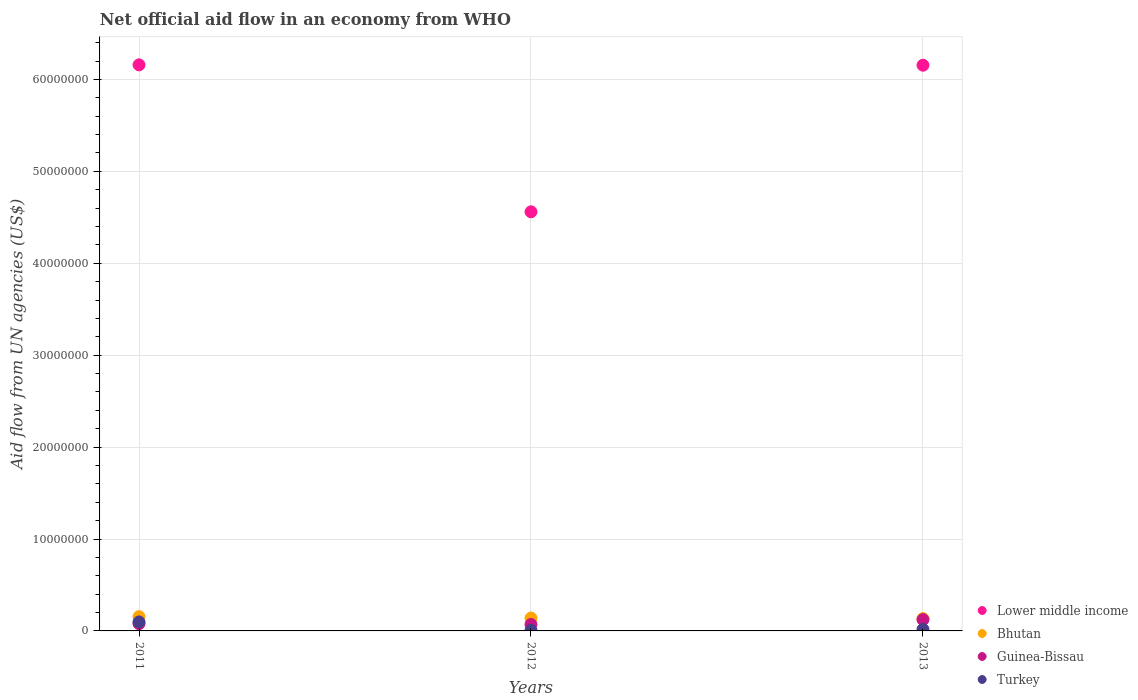What is the net official aid flow in Turkey in 2011?
Ensure brevity in your answer.  9.80e+05. Across all years, what is the maximum net official aid flow in Guinea-Bissau?
Your answer should be very brief. 1.23e+06. What is the total net official aid flow in Turkey in the graph?
Make the answer very short. 1.21e+06. What is the difference between the net official aid flow in Bhutan in 2012 and that in 2013?
Your answer should be compact. 6.00e+04. What is the difference between the net official aid flow in Turkey in 2011 and the net official aid flow in Bhutan in 2013?
Your answer should be compact. -3.60e+05. What is the average net official aid flow in Lower middle income per year?
Offer a very short reply. 5.62e+07. In the year 2012, what is the difference between the net official aid flow in Guinea-Bissau and net official aid flow in Turkey?
Your answer should be compact. 6.40e+05. What is the ratio of the net official aid flow in Guinea-Bissau in 2011 to that in 2013?
Provide a succinct answer. 0.64. Is the net official aid flow in Lower middle income in 2011 less than that in 2012?
Provide a succinct answer. No. Is the difference between the net official aid flow in Guinea-Bissau in 2012 and 2013 greater than the difference between the net official aid flow in Turkey in 2012 and 2013?
Make the answer very short. No. What is the difference between the highest and the second highest net official aid flow in Lower middle income?
Offer a very short reply. 4.00e+04. What is the difference between the highest and the lowest net official aid flow in Guinea-Bissau?
Offer a terse response. 5.30e+05. In how many years, is the net official aid flow in Turkey greater than the average net official aid flow in Turkey taken over all years?
Provide a short and direct response. 1. Is it the case that in every year, the sum of the net official aid flow in Lower middle income and net official aid flow in Guinea-Bissau  is greater than the net official aid flow in Turkey?
Give a very brief answer. Yes. Does the net official aid flow in Lower middle income monotonically increase over the years?
Your answer should be very brief. No. Is the net official aid flow in Guinea-Bissau strictly less than the net official aid flow in Bhutan over the years?
Your answer should be compact. Yes. How many dotlines are there?
Keep it short and to the point. 4. How many years are there in the graph?
Provide a short and direct response. 3. Where does the legend appear in the graph?
Give a very brief answer. Bottom right. What is the title of the graph?
Keep it short and to the point. Net official aid flow in an economy from WHO. What is the label or title of the Y-axis?
Give a very brief answer. Aid flow from UN agencies (US$). What is the Aid flow from UN agencies (US$) of Lower middle income in 2011?
Your response must be concise. 6.16e+07. What is the Aid flow from UN agencies (US$) of Bhutan in 2011?
Make the answer very short. 1.55e+06. What is the Aid flow from UN agencies (US$) of Guinea-Bissau in 2011?
Provide a short and direct response. 7.90e+05. What is the Aid flow from UN agencies (US$) in Turkey in 2011?
Your answer should be very brief. 9.80e+05. What is the Aid flow from UN agencies (US$) of Lower middle income in 2012?
Provide a short and direct response. 4.56e+07. What is the Aid flow from UN agencies (US$) in Bhutan in 2012?
Your answer should be compact. 1.40e+06. What is the Aid flow from UN agencies (US$) of Lower middle income in 2013?
Your answer should be compact. 6.16e+07. What is the Aid flow from UN agencies (US$) in Bhutan in 2013?
Ensure brevity in your answer.  1.34e+06. What is the Aid flow from UN agencies (US$) of Guinea-Bissau in 2013?
Offer a terse response. 1.23e+06. Across all years, what is the maximum Aid flow from UN agencies (US$) in Lower middle income?
Your answer should be very brief. 6.16e+07. Across all years, what is the maximum Aid flow from UN agencies (US$) of Bhutan?
Give a very brief answer. 1.55e+06. Across all years, what is the maximum Aid flow from UN agencies (US$) of Guinea-Bissau?
Give a very brief answer. 1.23e+06. Across all years, what is the maximum Aid flow from UN agencies (US$) in Turkey?
Ensure brevity in your answer.  9.80e+05. Across all years, what is the minimum Aid flow from UN agencies (US$) of Lower middle income?
Your answer should be compact. 4.56e+07. Across all years, what is the minimum Aid flow from UN agencies (US$) in Bhutan?
Keep it short and to the point. 1.34e+06. Across all years, what is the minimum Aid flow from UN agencies (US$) of Turkey?
Ensure brevity in your answer.  6.00e+04. What is the total Aid flow from UN agencies (US$) in Lower middle income in the graph?
Make the answer very short. 1.69e+08. What is the total Aid flow from UN agencies (US$) of Bhutan in the graph?
Make the answer very short. 4.29e+06. What is the total Aid flow from UN agencies (US$) of Guinea-Bissau in the graph?
Offer a very short reply. 2.72e+06. What is the total Aid flow from UN agencies (US$) of Turkey in the graph?
Give a very brief answer. 1.21e+06. What is the difference between the Aid flow from UN agencies (US$) in Lower middle income in 2011 and that in 2012?
Provide a short and direct response. 1.60e+07. What is the difference between the Aid flow from UN agencies (US$) of Guinea-Bissau in 2011 and that in 2012?
Provide a succinct answer. 9.00e+04. What is the difference between the Aid flow from UN agencies (US$) of Turkey in 2011 and that in 2012?
Your answer should be very brief. 9.20e+05. What is the difference between the Aid flow from UN agencies (US$) of Lower middle income in 2011 and that in 2013?
Provide a short and direct response. 4.00e+04. What is the difference between the Aid flow from UN agencies (US$) of Bhutan in 2011 and that in 2013?
Provide a succinct answer. 2.10e+05. What is the difference between the Aid flow from UN agencies (US$) of Guinea-Bissau in 2011 and that in 2013?
Keep it short and to the point. -4.40e+05. What is the difference between the Aid flow from UN agencies (US$) in Turkey in 2011 and that in 2013?
Offer a very short reply. 8.10e+05. What is the difference between the Aid flow from UN agencies (US$) of Lower middle income in 2012 and that in 2013?
Your response must be concise. -1.60e+07. What is the difference between the Aid flow from UN agencies (US$) of Bhutan in 2012 and that in 2013?
Your answer should be compact. 6.00e+04. What is the difference between the Aid flow from UN agencies (US$) in Guinea-Bissau in 2012 and that in 2013?
Ensure brevity in your answer.  -5.30e+05. What is the difference between the Aid flow from UN agencies (US$) in Turkey in 2012 and that in 2013?
Offer a terse response. -1.10e+05. What is the difference between the Aid flow from UN agencies (US$) in Lower middle income in 2011 and the Aid flow from UN agencies (US$) in Bhutan in 2012?
Give a very brief answer. 6.02e+07. What is the difference between the Aid flow from UN agencies (US$) of Lower middle income in 2011 and the Aid flow from UN agencies (US$) of Guinea-Bissau in 2012?
Provide a succinct answer. 6.09e+07. What is the difference between the Aid flow from UN agencies (US$) in Lower middle income in 2011 and the Aid flow from UN agencies (US$) in Turkey in 2012?
Offer a very short reply. 6.15e+07. What is the difference between the Aid flow from UN agencies (US$) of Bhutan in 2011 and the Aid flow from UN agencies (US$) of Guinea-Bissau in 2012?
Keep it short and to the point. 8.50e+05. What is the difference between the Aid flow from UN agencies (US$) in Bhutan in 2011 and the Aid flow from UN agencies (US$) in Turkey in 2012?
Provide a short and direct response. 1.49e+06. What is the difference between the Aid flow from UN agencies (US$) of Guinea-Bissau in 2011 and the Aid flow from UN agencies (US$) of Turkey in 2012?
Offer a very short reply. 7.30e+05. What is the difference between the Aid flow from UN agencies (US$) of Lower middle income in 2011 and the Aid flow from UN agencies (US$) of Bhutan in 2013?
Your response must be concise. 6.02e+07. What is the difference between the Aid flow from UN agencies (US$) of Lower middle income in 2011 and the Aid flow from UN agencies (US$) of Guinea-Bissau in 2013?
Give a very brief answer. 6.04e+07. What is the difference between the Aid flow from UN agencies (US$) of Lower middle income in 2011 and the Aid flow from UN agencies (US$) of Turkey in 2013?
Make the answer very short. 6.14e+07. What is the difference between the Aid flow from UN agencies (US$) of Bhutan in 2011 and the Aid flow from UN agencies (US$) of Guinea-Bissau in 2013?
Offer a very short reply. 3.20e+05. What is the difference between the Aid flow from UN agencies (US$) in Bhutan in 2011 and the Aid flow from UN agencies (US$) in Turkey in 2013?
Your answer should be very brief. 1.38e+06. What is the difference between the Aid flow from UN agencies (US$) of Guinea-Bissau in 2011 and the Aid flow from UN agencies (US$) of Turkey in 2013?
Offer a terse response. 6.20e+05. What is the difference between the Aid flow from UN agencies (US$) of Lower middle income in 2012 and the Aid flow from UN agencies (US$) of Bhutan in 2013?
Give a very brief answer. 4.43e+07. What is the difference between the Aid flow from UN agencies (US$) in Lower middle income in 2012 and the Aid flow from UN agencies (US$) in Guinea-Bissau in 2013?
Provide a short and direct response. 4.44e+07. What is the difference between the Aid flow from UN agencies (US$) in Lower middle income in 2012 and the Aid flow from UN agencies (US$) in Turkey in 2013?
Provide a succinct answer. 4.54e+07. What is the difference between the Aid flow from UN agencies (US$) of Bhutan in 2012 and the Aid flow from UN agencies (US$) of Turkey in 2013?
Provide a succinct answer. 1.23e+06. What is the difference between the Aid flow from UN agencies (US$) of Guinea-Bissau in 2012 and the Aid flow from UN agencies (US$) of Turkey in 2013?
Keep it short and to the point. 5.30e+05. What is the average Aid flow from UN agencies (US$) of Lower middle income per year?
Your answer should be very brief. 5.62e+07. What is the average Aid flow from UN agencies (US$) in Bhutan per year?
Your answer should be very brief. 1.43e+06. What is the average Aid flow from UN agencies (US$) of Guinea-Bissau per year?
Ensure brevity in your answer.  9.07e+05. What is the average Aid flow from UN agencies (US$) of Turkey per year?
Give a very brief answer. 4.03e+05. In the year 2011, what is the difference between the Aid flow from UN agencies (US$) in Lower middle income and Aid flow from UN agencies (US$) in Bhutan?
Offer a terse response. 6.00e+07. In the year 2011, what is the difference between the Aid flow from UN agencies (US$) in Lower middle income and Aid flow from UN agencies (US$) in Guinea-Bissau?
Provide a succinct answer. 6.08e+07. In the year 2011, what is the difference between the Aid flow from UN agencies (US$) of Lower middle income and Aid flow from UN agencies (US$) of Turkey?
Provide a succinct answer. 6.06e+07. In the year 2011, what is the difference between the Aid flow from UN agencies (US$) in Bhutan and Aid flow from UN agencies (US$) in Guinea-Bissau?
Give a very brief answer. 7.60e+05. In the year 2011, what is the difference between the Aid flow from UN agencies (US$) in Bhutan and Aid flow from UN agencies (US$) in Turkey?
Ensure brevity in your answer.  5.70e+05. In the year 2011, what is the difference between the Aid flow from UN agencies (US$) in Guinea-Bissau and Aid flow from UN agencies (US$) in Turkey?
Keep it short and to the point. -1.90e+05. In the year 2012, what is the difference between the Aid flow from UN agencies (US$) of Lower middle income and Aid flow from UN agencies (US$) of Bhutan?
Your answer should be very brief. 4.42e+07. In the year 2012, what is the difference between the Aid flow from UN agencies (US$) in Lower middle income and Aid flow from UN agencies (US$) in Guinea-Bissau?
Your answer should be compact. 4.49e+07. In the year 2012, what is the difference between the Aid flow from UN agencies (US$) in Lower middle income and Aid flow from UN agencies (US$) in Turkey?
Give a very brief answer. 4.55e+07. In the year 2012, what is the difference between the Aid flow from UN agencies (US$) of Bhutan and Aid flow from UN agencies (US$) of Guinea-Bissau?
Offer a very short reply. 7.00e+05. In the year 2012, what is the difference between the Aid flow from UN agencies (US$) of Bhutan and Aid flow from UN agencies (US$) of Turkey?
Make the answer very short. 1.34e+06. In the year 2012, what is the difference between the Aid flow from UN agencies (US$) in Guinea-Bissau and Aid flow from UN agencies (US$) in Turkey?
Your answer should be very brief. 6.40e+05. In the year 2013, what is the difference between the Aid flow from UN agencies (US$) of Lower middle income and Aid flow from UN agencies (US$) of Bhutan?
Your answer should be compact. 6.02e+07. In the year 2013, what is the difference between the Aid flow from UN agencies (US$) of Lower middle income and Aid flow from UN agencies (US$) of Guinea-Bissau?
Your response must be concise. 6.03e+07. In the year 2013, what is the difference between the Aid flow from UN agencies (US$) of Lower middle income and Aid flow from UN agencies (US$) of Turkey?
Ensure brevity in your answer.  6.14e+07. In the year 2013, what is the difference between the Aid flow from UN agencies (US$) of Bhutan and Aid flow from UN agencies (US$) of Guinea-Bissau?
Make the answer very short. 1.10e+05. In the year 2013, what is the difference between the Aid flow from UN agencies (US$) in Bhutan and Aid flow from UN agencies (US$) in Turkey?
Your response must be concise. 1.17e+06. In the year 2013, what is the difference between the Aid flow from UN agencies (US$) in Guinea-Bissau and Aid flow from UN agencies (US$) in Turkey?
Provide a short and direct response. 1.06e+06. What is the ratio of the Aid flow from UN agencies (US$) in Lower middle income in 2011 to that in 2012?
Your response must be concise. 1.35. What is the ratio of the Aid flow from UN agencies (US$) of Bhutan in 2011 to that in 2012?
Your answer should be compact. 1.11. What is the ratio of the Aid flow from UN agencies (US$) in Guinea-Bissau in 2011 to that in 2012?
Keep it short and to the point. 1.13. What is the ratio of the Aid flow from UN agencies (US$) of Turkey in 2011 to that in 2012?
Make the answer very short. 16.33. What is the ratio of the Aid flow from UN agencies (US$) of Lower middle income in 2011 to that in 2013?
Your response must be concise. 1. What is the ratio of the Aid flow from UN agencies (US$) of Bhutan in 2011 to that in 2013?
Give a very brief answer. 1.16. What is the ratio of the Aid flow from UN agencies (US$) of Guinea-Bissau in 2011 to that in 2013?
Ensure brevity in your answer.  0.64. What is the ratio of the Aid flow from UN agencies (US$) in Turkey in 2011 to that in 2013?
Keep it short and to the point. 5.76. What is the ratio of the Aid flow from UN agencies (US$) in Lower middle income in 2012 to that in 2013?
Offer a very short reply. 0.74. What is the ratio of the Aid flow from UN agencies (US$) in Bhutan in 2012 to that in 2013?
Make the answer very short. 1.04. What is the ratio of the Aid flow from UN agencies (US$) in Guinea-Bissau in 2012 to that in 2013?
Provide a succinct answer. 0.57. What is the ratio of the Aid flow from UN agencies (US$) in Turkey in 2012 to that in 2013?
Your response must be concise. 0.35. What is the difference between the highest and the second highest Aid flow from UN agencies (US$) in Lower middle income?
Provide a succinct answer. 4.00e+04. What is the difference between the highest and the second highest Aid flow from UN agencies (US$) in Bhutan?
Your answer should be very brief. 1.50e+05. What is the difference between the highest and the second highest Aid flow from UN agencies (US$) of Turkey?
Provide a succinct answer. 8.10e+05. What is the difference between the highest and the lowest Aid flow from UN agencies (US$) in Lower middle income?
Make the answer very short. 1.60e+07. What is the difference between the highest and the lowest Aid flow from UN agencies (US$) in Bhutan?
Offer a terse response. 2.10e+05. What is the difference between the highest and the lowest Aid flow from UN agencies (US$) in Guinea-Bissau?
Provide a succinct answer. 5.30e+05. What is the difference between the highest and the lowest Aid flow from UN agencies (US$) of Turkey?
Make the answer very short. 9.20e+05. 